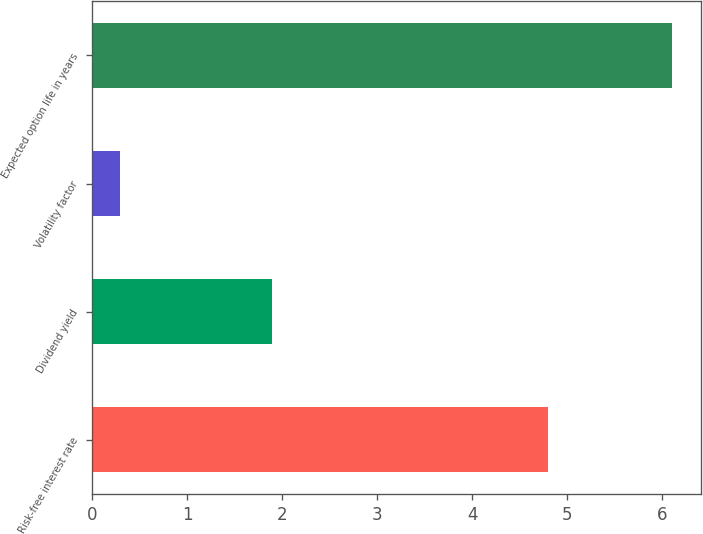Convert chart to OTSL. <chart><loc_0><loc_0><loc_500><loc_500><bar_chart><fcel>Risk-free interest rate<fcel>Dividend yield<fcel>Volatility factor<fcel>Expected option life in years<nl><fcel>4.8<fcel>1.9<fcel>0.3<fcel>6.1<nl></chart> 